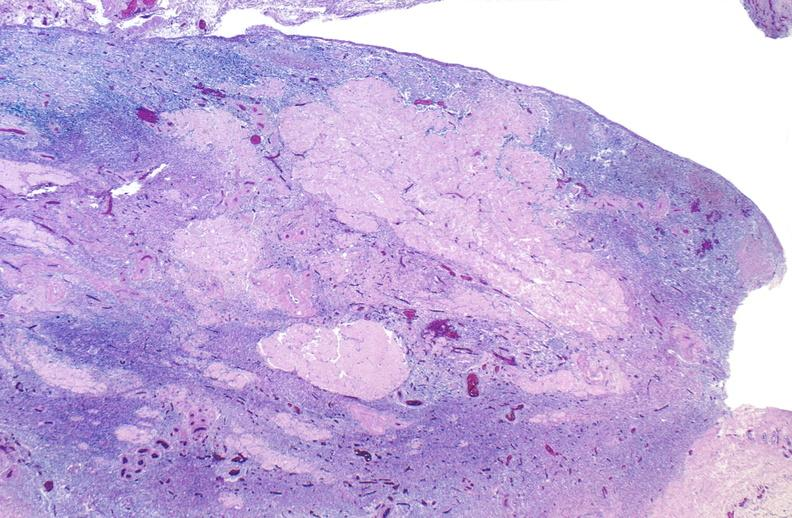s female reproductive present?
Answer the question using a single word or phrase. Yes 